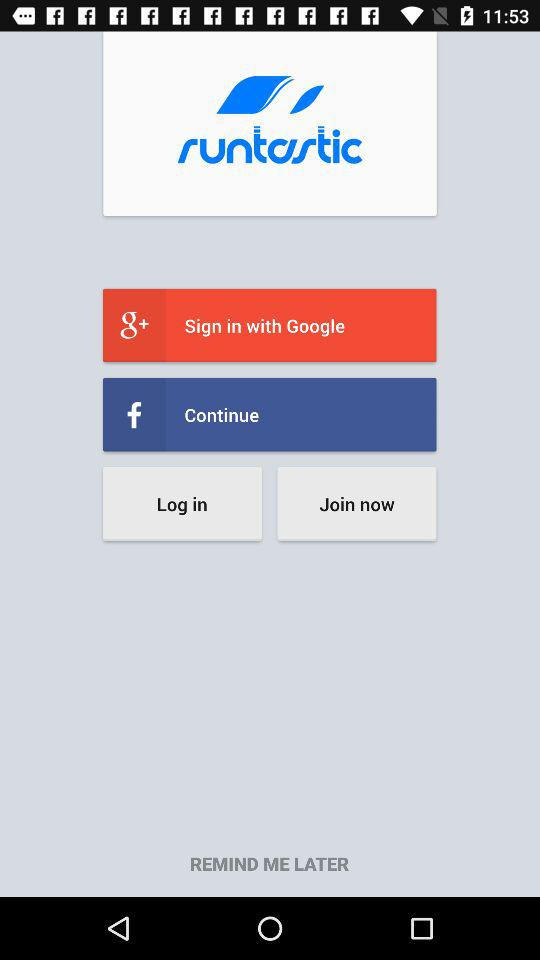What is the application name? The application name is "runtastic". 